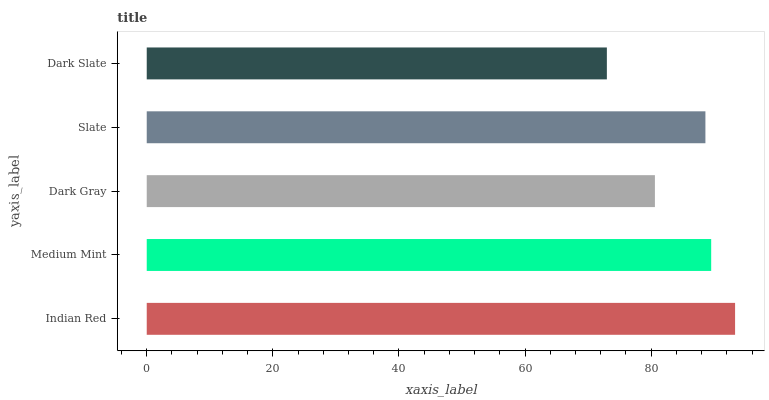Is Dark Slate the minimum?
Answer yes or no. Yes. Is Indian Red the maximum?
Answer yes or no. Yes. Is Medium Mint the minimum?
Answer yes or no. No. Is Medium Mint the maximum?
Answer yes or no. No. Is Indian Red greater than Medium Mint?
Answer yes or no. Yes. Is Medium Mint less than Indian Red?
Answer yes or no. Yes. Is Medium Mint greater than Indian Red?
Answer yes or no. No. Is Indian Red less than Medium Mint?
Answer yes or no. No. Is Slate the high median?
Answer yes or no. Yes. Is Slate the low median?
Answer yes or no. Yes. Is Medium Mint the high median?
Answer yes or no. No. Is Medium Mint the low median?
Answer yes or no. No. 